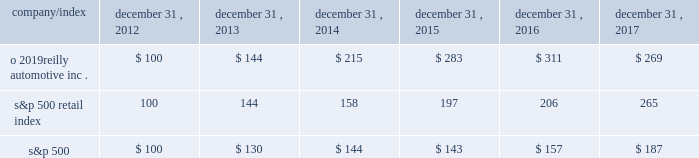Stock performance graph : the graph below shows the cumulative total shareholder return assuming the investment of $ 100 , on december 31 , 2012 , and the reinvestment of dividends thereafter , if any , in the company 2019s common stock versus the standard and poor 2019s s&p 500 retail index ( 201cs&p 500 retail index 201d ) and the standard and poor 2019s s&p 500 index ( 201cs&p 500 201d ) . .

What was the difference in the five year total return for o 2019reilly automotive inc . vs the s&p 500 retail index? 
Computations: (269 - 265)
Answer: 4.0. Stock performance graph : the graph below shows the cumulative total shareholder return assuming the investment of $ 100 , on december 31 , 2012 , and the reinvestment of dividends thereafter , if any , in the company 2019s common stock versus the standard and poor 2019s s&p 500 retail index ( 201cs&p 500 retail index 201d ) and the standard and poor 2019s s&p 500 index ( 201cs&p 500 201d ) . .

Was the o 2019reilly automotive inc five year return less than the s&p 500 retail index? 
Computations: (265 > 269)
Answer: no. 